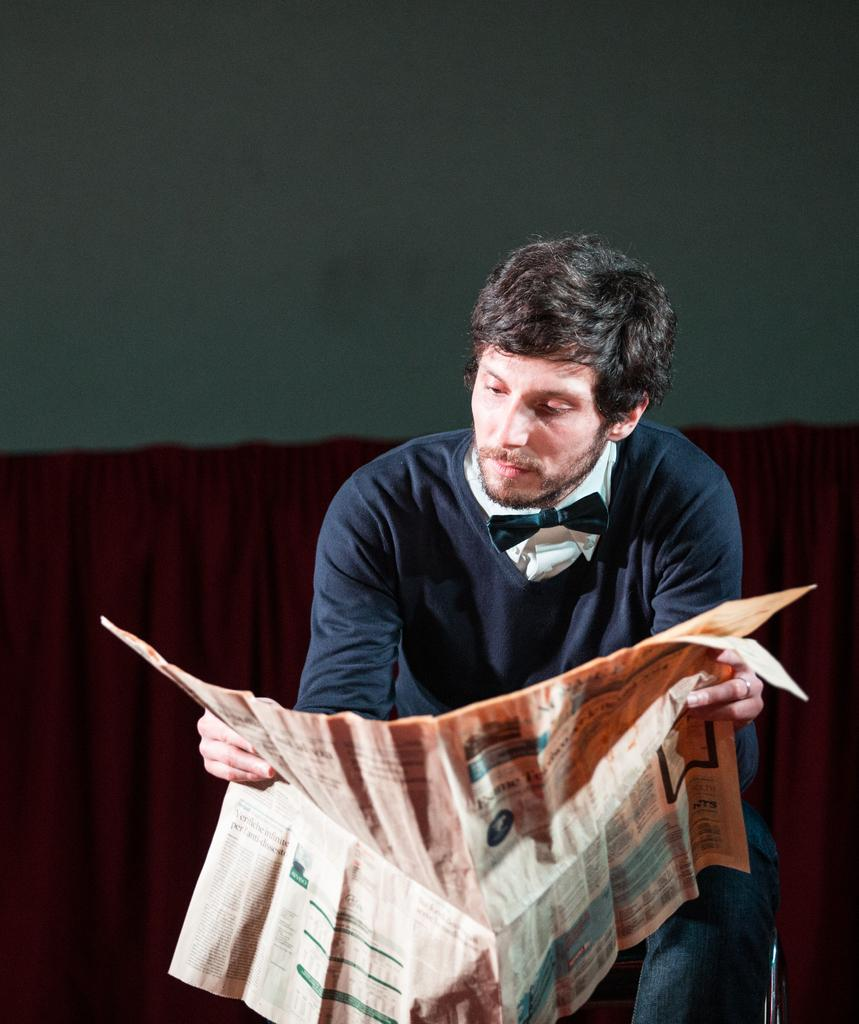What is the man in the image doing? The man is sitting on a chair in the image. What is the man holding in the image? The man is holding a newspaper. What can be seen in the middle of the image? A curtain is present in the middle of the image. What is visible at the top of the image? There is a wall at the top of the image. What type of pet can be seen playing with the man in the image? There is no pet present in the image; the man is sitting alone holding a newspaper. 